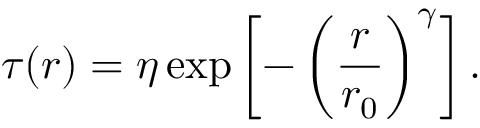<formula> <loc_0><loc_0><loc_500><loc_500>\tau ( r ) = \eta \exp \left [ - \left ( \frac { r } { r _ { 0 } } \right ) ^ { \gamma } \right ] .</formula> 